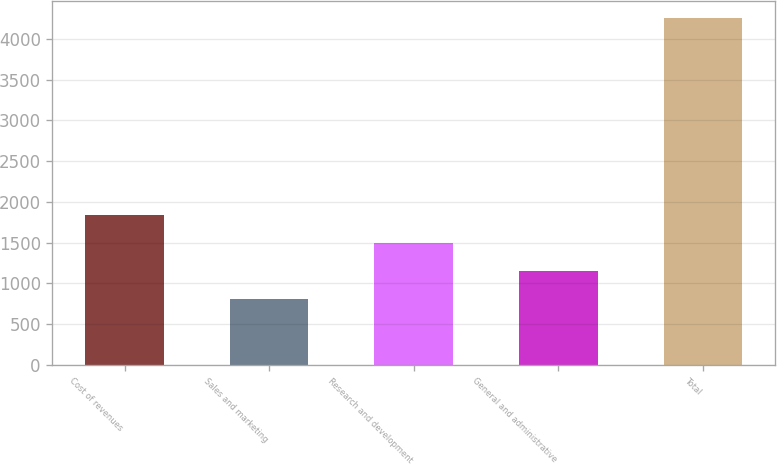Convert chart. <chart><loc_0><loc_0><loc_500><loc_500><bar_chart><fcel>Cost of revenues<fcel>Sales and marketing<fcel>Research and development<fcel>General and administrative<fcel>Total<nl><fcel>1841.6<fcel>809<fcel>1497.4<fcel>1153.2<fcel>4251<nl></chart> 